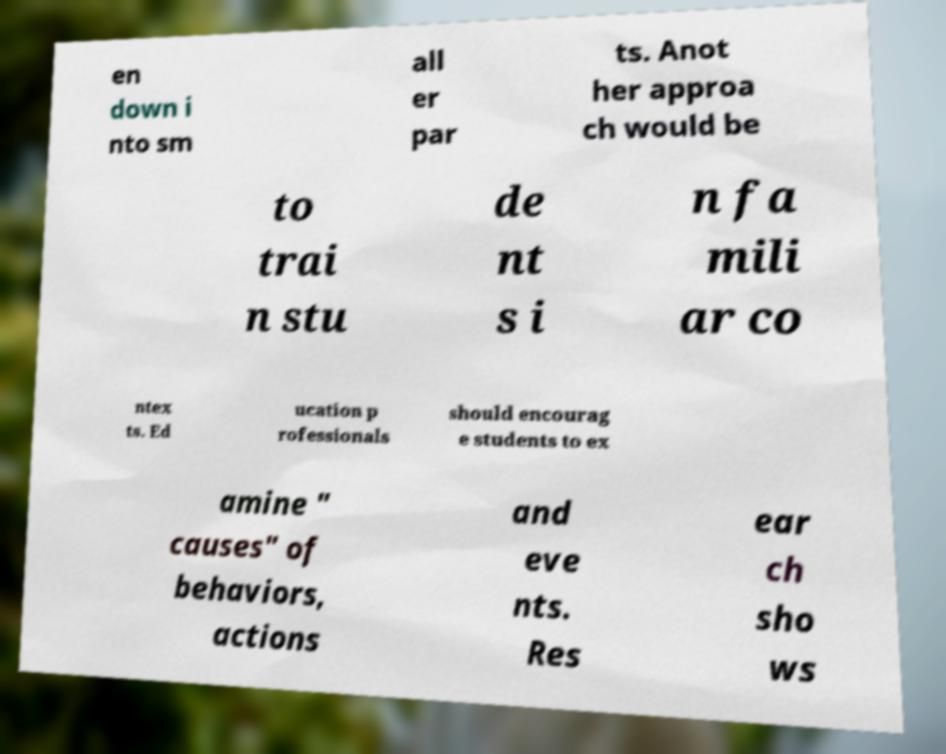What messages or text are displayed in this image? I need them in a readable, typed format. en down i nto sm all er par ts. Anot her approa ch would be to trai n stu de nt s i n fa mili ar co ntex ts. Ed ucation p rofessionals should encourag e students to ex amine " causes" of behaviors, actions and eve nts. Res ear ch sho ws 